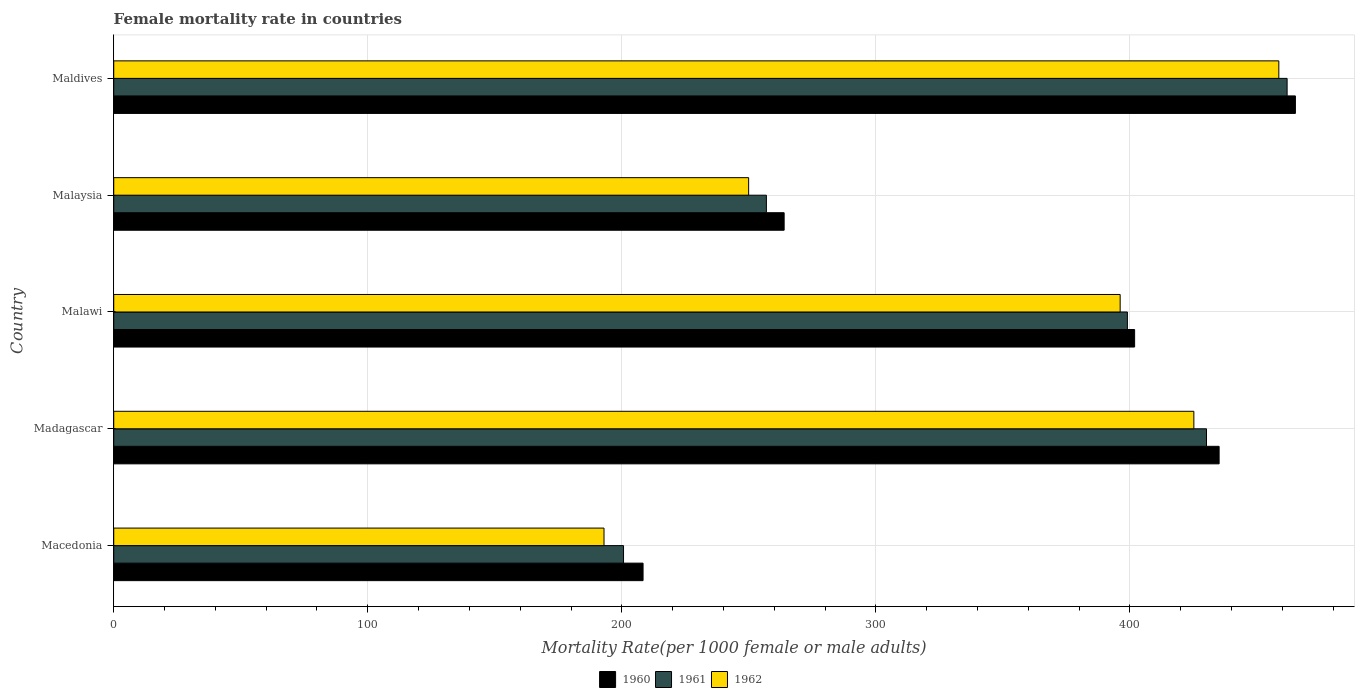How many different coloured bars are there?
Make the answer very short. 3. Are the number of bars on each tick of the Y-axis equal?
Your answer should be very brief. Yes. How many bars are there on the 4th tick from the bottom?
Offer a very short reply. 3. What is the label of the 5th group of bars from the top?
Your response must be concise. Macedonia. What is the female mortality rate in 1961 in Malaysia?
Offer a very short reply. 256.92. Across all countries, what is the maximum female mortality rate in 1961?
Give a very brief answer. 461.9. Across all countries, what is the minimum female mortality rate in 1960?
Keep it short and to the point. 208.37. In which country was the female mortality rate in 1962 maximum?
Your answer should be compact. Maldives. In which country was the female mortality rate in 1960 minimum?
Provide a succinct answer. Macedonia. What is the total female mortality rate in 1961 in the graph?
Provide a succinct answer. 1748.69. What is the difference between the female mortality rate in 1960 in Malaysia and that in Maldives?
Keep it short and to the point. -201.26. What is the difference between the female mortality rate in 1960 in Malawi and the female mortality rate in 1962 in Maldives?
Your answer should be very brief. -56.76. What is the average female mortality rate in 1961 per country?
Your answer should be very brief. 349.74. What is the difference between the female mortality rate in 1960 and female mortality rate in 1962 in Madagascar?
Keep it short and to the point. 9.94. What is the ratio of the female mortality rate in 1960 in Madagascar to that in Maldives?
Provide a succinct answer. 0.94. Is the female mortality rate in 1960 in Madagascar less than that in Maldives?
Your response must be concise. Yes. Is the difference between the female mortality rate in 1960 in Madagascar and Malaysia greater than the difference between the female mortality rate in 1962 in Madagascar and Malaysia?
Provide a succinct answer. No. What is the difference between the highest and the second highest female mortality rate in 1962?
Your answer should be compact. 33.44. What is the difference between the highest and the lowest female mortality rate in 1960?
Your answer should be compact. 256.8. Is the sum of the female mortality rate in 1962 in Macedonia and Madagascar greater than the maximum female mortality rate in 1960 across all countries?
Give a very brief answer. Yes. What does the 1st bar from the top in Maldives represents?
Provide a succinct answer. 1962. What does the 1st bar from the bottom in Maldives represents?
Offer a terse response. 1960. How many bars are there?
Give a very brief answer. 15. Are all the bars in the graph horizontal?
Your answer should be very brief. Yes. Are the values on the major ticks of X-axis written in scientific E-notation?
Your answer should be very brief. No. How are the legend labels stacked?
Make the answer very short. Horizontal. What is the title of the graph?
Make the answer very short. Female mortality rate in countries. What is the label or title of the X-axis?
Make the answer very short. Mortality Rate(per 1000 female or male adults). What is the label or title of the Y-axis?
Your answer should be very brief. Country. What is the Mortality Rate(per 1000 female or male adults) of 1960 in Macedonia?
Your answer should be very brief. 208.37. What is the Mortality Rate(per 1000 female or male adults) in 1961 in Macedonia?
Provide a short and direct response. 200.68. What is the Mortality Rate(per 1000 female or male adults) in 1962 in Macedonia?
Provide a succinct answer. 193. What is the Mortality Rate(per 1000 female or male adults) in 1960 in Madagascar?
Provide a succinct answer. 435.14. What is the Mortality Rate(per 1000 female or male adults) in 1961 in Madagascar?
Provide a succinct answer. 430.17. What is the Mortality Rate(per 1000 female or male adults) in 1962 in Madagascar?
Offer a very short reply. 425.19. What is the Mortality Rate(per 1000 female or male adults) in 1960 in Malawi?
Your response must be concise. 401.87. What is the Mortality Rate(per 1000 female or male adults) in 1961 in Malawi?
Offer a terse response. 399.02. What is the Mortality Rate(per 1000 female or male adults) of 1962 in Malawi?
Offer a terse response. 396.18. What is the Mortality Rate(per 1000 female or male adults) of 1960 in Malaysia?
Your answer should be very brief. 263.9. What is the Mortality Rate(per 1000 female or male adults) of 1961 in Malaysia?
Offer a very short reply. 256.92. What is the Mortality Rate(per 1000 female or male adults) in 1962 in Malaysia?
Make the answer very short. 249.93. What is the Mortality Rate(per 1000 female or male adults) of 1960 in Maldives?
Give a very brief answer. 465.17. What is the Mortality Rate(per 1000 female or male adults) in 1961 in Maldives?
Offer a terse response. 461.9. What is the Mortality Rate(per 1000 female or male adults) in 1962 in Maldives?
Give a very brief answer. 458.64. Across all countries, what is the maximum Mortality Rate(per 1000 female or male adults) of 1960?
Your answer should be compact. 465.17. Across all countries, what is the maximum Mortality Rate(per 1000 female or male adults) in 1961?
Your response must be concise. 461.9. Across all countries, what is the maximum Mortality Rate(per 1000 female or male adults) of 1962?
Make the answer very short. 458.64. Across all countries, what is the minimum Mortality Rate(per 1000 female or male adults) of 1960?
Make the answer very short. 208.37. Across all countries, what is the minimum Mortality Rate(per 1000 female or male adults) in 1961?
Make the answer very short. 200.68. Across all countries, what is the minimum Mortality Rate(per 1000 female or male adults) in 1962?
Provide a succinct answer. 193. What is the total Mortality Rate(per 1000 female or male adults) of 1960 in the graph?
Your answer should be compact. 1774.45. What is the total Mortality Rate(per 1000 female or male adults) of 1961 in the graph?
Provide a succinct answer. 1748.69. What is the total Mortality Rate(per 1000 female or male adults) of 1962 in the graph?
Provide a short and direct response. 1722.93. What is the difference between the Mortality Rate(per 1000 female or male adults) in 1960 in Macedonia and that in Madagascar?
Provide a short and direct response. -226.77. What is the difference between the Mortality Rate(per 1000 female or male adults) in 1961 in Macedonia and that in Madagascar?
Give a very brief answer. -229.48. What is the difference between the Mortality Rate(per 1000 female or male adults) of 1962 in Macedonia and that in Madagascar?
Offer a very short reply. -232.2. What is the difference between the Mortality Rate(per 1000 female or male adults) of 1960 in Macedonia and that in Malawi?
Offer a very short reply. -193.51. What is the difference between the Mortality Rate(per 1000 female or male adults) of 1961 in Macedonia and that in Malawi?
Make the answer very short. -198.34. What is the difference between the Mortality Rate(per 1000 female or male adults) in 1962 in Macedonia and that in Malawi?
Ensure brevity in your answer.  -203.18. What is the difference between the Mortality Rate(per 1000 female or male adults) in 1960 in Macedonia and that in Malaysia?
Ensure brevity in your answer.  -55.54. What is the difference between the Mortality Rate(per 1000 female or male adults) of 1961 in Macedonia and that in Malaysia?
Your response must be concise. -56.23. What is the difference between the Mortality Rate(per 1000 female or male adults) of 1962 in Macedonia and that in Malaysia?
Make the answer very short. -56.93. What is the difference between the Mortality Rate(per 1000 female or male adults) of 1960 in Macedonia and that in Maldives?
Provide a short and direct response. -256.8. What is the difference between the Mortality Rate(per 1000 female or male adults) of 1961 in Macedonia and that in Maldives?
Keep it short and to the point. -261.22. What is the difference between the Mortality Rate(per 1000 female or male adults) in 1962 in Macedonia and that in Maldives?
Make the answer very short. -265.64. What is the difference between the Mortality Rate(per 1000 female or male adults) of 1960 in Madagascar and that in Malawi?
Your response must be concise. 33.26. What is the difference between the Mortality Rate(per 1000 female or male adults) of 1961 in Madagascar and that in Malawi?
Make the answer very short. 31.14. What is the difference between the Mortality Rate(per 1000 female or male adults) of 1962 in Madagascar and that in Malawi?
Provide a succinct answer. 29.02. What is the difference between the Mortality Rate(per 1000 female or male adults) of 1960 in Madagascar and that in Malaysia?
Your response must be concise. 171.23. What is the difference between the Mortality Rate(per 1000 female or male adults) in 1961 in Madagascar and that in Malaysia?
Offer a terse response. 173.25. What is the difference between the Mortality Rate(per 1000 female or male adults) of 1962 in Madagascar and that in Malaysia?
Your response must be concise. 175.26. What is the difference between the Mortality Rate(per 1000 female or male adults) of 1960 in Madagascar and that in Maldives?
Offer a terse response. -30.03. What is the difference between the Mortality Rate(per 1000 female or male adults) of 1961 in Madagascar and that in Maldives?
Offer a very short reply. -31.74. What is the difference between the Mortality Rate(per 1000 female or male adults) in 1962 in Madagascar and that in Maldives?
Give a very brief answer. -33.44. What is the difference between the Mortality Rate(per 1000 female or male adults) of 1960 in Malawi and that in Malaysia?
Make the answer very short. 137.97. What is the difference between the Mortality Rate(per 1000 female or male adults) in 1961 in Malawi and that in Malaysia?
Give a very brief answer. 142.11. What is the difference between the Mortality Rate(per 1000 female or male adults) of 1962 in Malawi and that in Malaysia?
Provide a short and direct response. 146.25. What is the difference between the Mortality Rate(per 1000 female or male adults) of 1960 in Malawi and that in Maldives?
Your answer should be compact. -63.29. What is the difference between the Mortality Rate(per 1000 female or male adults) of 1961 in Malawi and that in Maldives?
Keep it short and to the point. -62.88. What is the difference between the Mortality Rate(per 1000 female or male adults) in 1962 in Malawi and that in Maldives?
Offer a very short reply. -62.46. What is the difference between the Mortality Rate(per 1000 female or male adults) of 1960 in Malaysia and that in Maldives?
Offer a terse response. -201.26. What is the difference between the Mortality Rate(per 1000 female or male adults) in 1961 in Malaysia and that in Maldives?
Offer a terse response. -204.98. What is the difference between the Mortality Rate(per 1000 female or male adults) of 1962 in Malaysia and that in Maldives?
Ensure brevity in your answer.  -208.71. What is the difference between the Mortality Rate(per 1000 female or male adults) in 1960 in Macedonia and the Mortality Rate(per 1000 female or male adults) in 1961 in Madagascar?
Make the answer very short. -221.8. What is the difference between the Mortality Rate(per 1000 female or male adults) of 1960 in Macedonia and the Mortality Rate(per 1000 female or male adults) of 1962 in Madagascar?
Give a very brief answer. -216.82. What is the difference between the Mortality Rate(per 1000 female or male adults) in 1961 in Macedonia and the Mortality Rate(per 1000 female or male adults) in 1962 in Madagascar?
Keep it short and to the point. -224.51. What is the difference between the Mortality Rate(per 1000 female or male adults) of 1960 in Macedonia and the Mortality Rate(per 1000 female or male adults) of 1961 in Malawi?
Ensure brevity in your answer.  -190.66. What is the difference between the Mortality Rate(per 1000 female or male adults) of 1960 in Macedonia and the Mortality Rate(per 1000 female or male adults) of 1962 in Malawi?
Provide a succinct answer. -187.81. What is the difference between the Mortality Rate(per 1000 female or male adults) in 1961 in Macedonia and the Mortality Rate(per 1000 female or male adults) in 1962 in Malawi?
Offer a terse response. -195.49. What is the difference between the Mortality Rate(per 1000 female or male adults) in 1960 in Macedonia and the Mortality Rate(per 1000 female or male adults) in 1961 in Malaysia?
Your answer should be very brief. -48.55. What is the difference between the Mortality Rate(per 1000 female or male adults) of 1960 in Macedonia and the Mortality Rate(per 1000 female or male adults) of 1962 in Malaysia?
Your response must be concise. -41.56. What is the difference between the Mortality Rate(per 1000 female or male adults) in 1961 in Macedonia and the Mortality Rate(per 1000 female or male adults) in 1962 in Malaysia?
Give a very brief answer. -49.24. What is the difference between the Mortality Rate(per 1000 female or male adults) of 1960 in Macedonia and the Mortality Rate(per 1000 female or male adults) of 1961 in Maldives?
Your answer should be compact. -253.53. What is the difference between the Mortality Rate(per 1000 female or male adults) in 1960 in Macedonia and the Mortality Rate(per 1000 female or male adults) in 1962 in Maldives?
Keep it short and to the point. -250.27. What is the difference between the Mortality Rate(per 1000 female or male adults) of 1961 in Macedonia and the Mortality Rate(per 1000 female or male adults) of 1962 in Maldives?
Your answer should be very brief. -257.95. What is the difference between the Mortality Rate(per 1000 female or male adults) of 1960 in Madagascar and the Mortality Rate(per 1000 female or male adults) of 1961 in Malawi?
Provide a succinct answer. 36.11. What is the difference between the Mortality Rate(per 1000 female or male adults) of 1960 in Madagascar and the Mortality Rate(per 1000 female or male adults) of 1962 in Malawi?
Keep it short and to the point. 38.96. What is the difference between the Mortality Rate(per 1000 female or male adults) in 1961 in Madagascar and the Mortality Rate(per 1000 female or male adults) in 1962 in Malawi?
Your answer should be very brief. 33.99. What is the difference between the Mortality Rate(per 1000 female or male adults) of 1960 in Madagascar and the Mortality Rate(per 1000 female or male adults) of 1961 in Malaysia?
Your answer should be very brief. 178.22. What is the difference between the Mortality Rate(per 1000 female or male adults) in 1960 in Madagascar and the Mortality Rate(per 1000 female or male adults) in 1962 in Malaysia?
Ensure brevity in your answer.  185.21. What is the difference between the Mortality Rate(per 1000 female or male adults) of 1961 in Madagascar and the Mortality Rate(per 1000 female or male adults) of 1962 in Malaysia?
Keep it short and to the point. 180.24. What is the difference between the Mortality Rate(per 1000 female or male adults) of 1960 in Madagascar and the Mortality Rate(per 1000 female or male adults) of 1961 in Maldives?
Offer a terse response. -26.77. What is the difference between the Mortality Rate(per 1000 female or male adults) of 1960 in Madagascar and the Mortality Rate(per 1000 female or male adults) of 1962 in Maldives?
Keep it short and to the point. -23.5. What is the difference between the Mortality Rate(per 1000 female or male adults) of 1961 in Madagascar and the Mortality Rate(per 1000 female or male adults) of 1962 in Maldives?
Offer a terse response. -28.47. What is the difference between the Mortality Rate(per 1000 female or male adults) in 1960 in Malawi and the Mortality Rate(per 1000 female or male adults) in 1961 in Malaysia?
Your answer should be very brief. 144.96. What is the difference between the Mortality Rate(per 1000 female or male adults) of 1960 in Malawi and the Mortality Rate(per 1000 female or male adults) of 1962 in Malaysia?
Provide a succinct answer. 151.95. What is the difference between the Mortality Rate(per 1000 female or male adults) in 1961 in Malawi and the Mortality Rate(per 1000 female or male adults) in 1962 in Malaysia?
Your response must be concise. 149.1. What is the difference between the Mortality Rate(per 1000 female or male adults) of 1960 in Malawi and the Mortality Rate(per 1000 female or male adults) of 1961 in Maldives?
Offer a terse response. -60.03. What is the difference between the Mortality Rate(per 1000 female or male adults) in 1960 in Malawi and the Mortality Rate(per 1000 female or male adults) in 1962 in Maldives?
Give a very brief answer. -56.76. What is the difference between the Mortality Rate(per 1000 female or male adults) in 1961 in Malawi and the Mortality Rate(per 1000 female or male adults) in 1962 in Maldives?
Make the answer very short. -59.61. What is the difference between the Mortality Rate(per 1000 female or male adults) of 1960 in Malaysia and the Mortality Rate(per 1000 female or male adults) of 1961 in Maldives?
Your answer should be very brief. -198. What is the difference between the Mortality Rate(per 1000 female or male adults) of 1960 in Malaysia and the Mortality Rate(per 1000 female or male adults) of 1962 in Maldives?
Provide a short and direct response. -194.73. What is the difference between the Mortality Rate(per 1000 female or male adults) of 1961 in Malaysia and the Mortality Rate(per 1000 female or male adults) of 1962 in Maldives?
Your answer should be very brief. -201.72. What is the average Mortality Rate(per 1000 female or male adults) of 1960 per country?
Make the answer very short. 354.89. What is the average Mortality Rate(per 1000 female or male adults) in 1961 per country?
Provide a short and direct response. 349.74. What is the average Mortality Rate(per 1000 female or male adults) of 1962 per country?
Provide a succinct answer. 344.59. What is the difference between the Mortality Rate(per 1000 female or male adults) in 1960 and Mortality Rate(per 1000 female or male adults) in 1961 in Macedonia?
Give a very brief answer. 7.68. What is the difference between the Mortality Rate(per 1000 female or male adults) in 1960 and Mortality Rate(per 1000 female or male adults) in 1962 in Macedonia?
Keep it short and to the point. 15.37. What is the difference between the Mortality Rate(per 1000 female or male adults) in 1961 and Mortality Rate(per 1000 female or male adults) in 1962 in Macedonia?
Make the answer very short. 7.69. What is the difference between the Mortality Rate(per 1000 female or male adults) in 1960 and Mortality Rate(per 1000 female or male adults) in 1961 in Madagascar?
Your response must be concise. 4.97. What is the difference between the Mortality Rate(per 1000 female or male adults) of 1960 and Mortality Rate(per 1000 female or male adults) of 1962 in Madagascar?
Your response must be concise. 9.94. What is the difference between the Mortality Rate(per 1000 female or male adults) of 1961 and Mortality Rate(per 1000 female or male adults) of 1962 in Madagascar?
Keep it short and to the point. 4.97. What is the difference between the Mortality Rate(per 1000 female or male adults) in 1960 and Mortality Rate(per 1000 female or male adults) in 1961 in Malawi?
Ensure brevity in your answer.  2.85. What is the difference between the Mortality Rate(per 1000 female or male adults) in 1960 and Mortality Rate(per 1000 female or male adults) in 1962 in Malawi?
Provide a succinct answer. 5.7. What is the difference between the Mortality Rate(per 1000 female or male adults) of 1961 and Mortality Rate(per 1000 female or male adults) of 1962 in Malawi?
Your response must be concise. 2.85. What is the difference between the Mortality Rate(per 1000 female or male adults) in 1960 and Mortality Rate(per 1000 female or male adults) in 1961 in Malaysia?
Offer a very short reply. 6.99. What is the difference between the Mortality Rate(per 1000 female or male adults) of 1960 and Mortality Rate(per 1000 female or male adults) of 1962 in Malaysia?
Provide a short and direct response. 13.98. What is the difference between the Mortality Rate(per 1000 female or male adults) of 1961 and Mortality Rate(per 1000 female or male adults) of 1962 in Malaysia?
Offer a very short reply. 6.99. What is the difference between the Mortality Rate(per 1000 female or male adults) in 1960 and Mortality Rate(per 1000 female or male adults) in 1961 in Maldives?
Keep it short and to the point. 3.27. What is the difference between the Mortality Rate(per 1000 female or male adults) in 1960 and Mortality Rate(per 1000 female or male adults) in 1962 in Maldives?
Your answer should be compact. 6.53. What is the difference between the Mortality Rate(per 1000 female or male adults) of 1961 and Mortality Rate(per 1000 female or male adults) of 1962 in Maldives?
Your response must be concise. 3.27. What is the ratio of the Mortality Rate(per 1000 female or male adults) of 1960 in Macedonia to that in Madagascar?
Give a very brief answer. 0.48. What is the ratio of the Mortality Rate(per 1000 female or male adults) in 1961 in Macedonia to that in Madagascar?
Make the answer very short. 0.47. What is the ratio of the Mortality Rate(per 1000 female or male adults) in 1962 in Macedonia to that in Madagascar?
Give a very brief answer. 0.45. What is the ratio of the Mortality Rate(per 1000 female or male adults) in 1960 in Macedonia to that in Malawi?
Make the answer very short. 0.52. What is the ratio of the Mortality Rate(per 1000 female or male adults) in 1961 in Macedonia to that in Malawi?
Give a very brief answer. 0.5. What is the ratio of the Mortality Rate(per 1000 female or male adults) in 1962 in Macedonia to that in Malawi?
Your response must be concise. 0.49. What is the ratio of the Mortality Rate(per 1000 female or male adults) in 1960 in Macedonia to that in Malaysia?
Your response must be concise. 0.79. What is the ratio of the Mortality Rate(per 1000 female or male adults) of 1961 in Macedonia to that in Malaysia?
Make the answer very short. 0.78. What is the ratio of the Mortality Rate(per 1000 female or male adults) of 1962 in Macedonia to that in Malaysia?
Offer a terse response. 0.77. What is the ratio of the Mortality Rate(per 1000 female or male adults) in 1960 in Macedonia to that in Maldives?
Your answer should be very brief. 0.45. What is the ratio of the Mortality Rate(per 1000 female or male adults) of 1961 in Macedonia to that in Maldives?
Offer a terse response. 0.43. What is the ratio of the Mortality Rate(per 1000 female or male adults) of 1962 in Macedonia to that in Maldives?
Your answer should be compact. 0.42. What is the ratio of the Mortality Rate(per 1000 female or male adults) of 1960 in Madagascar to that in Malawi?
Your answer should be compact. 1.08. What is the ratio of the Mortality Rate(per 1000 female or male adults) of 1961 in Madagascar to that in Malawi?
Ensure brevity in your answer.  1.08. What is the ratio of the Mortality Rate(per 1000 female or male adults) in 1962 in Madagascar to that in Malawi?
Your answer should be compact. 1.07. What is the ratio of the Mortality Rate(per 1000 female or male adults) of 1960 in Madagascar to that in Malaysia?
Give a very brief answer. 1.65. What is the ratio of the Mortality Rate(per 1000 female or male adults) in 1961 in Madagascar to that in Malaysia?
Ensure brevity in your answer.  1.67. What is the ratio of the Mortality Rate(per 1000 female or male adults) of 1962 in Madagascar to that in Malaysia?
Offer a very short reply. 1.7. What is the ratio of the Mortality Rate(per 1000 female or male adults) of 1960 in Madagascar to that in Maldives?
Provide a succinct answer. 0.94. What is the ratio of the Mortality Rate(per 1000 female or male adults) in 1961 in Madagascar to that in Maldives?
Your answer should be very brief. 0.93. What is the ratio of the Mortality Rate(per 1000 female or male adults) in 1962 in Madagascar to that in Maldives?
Offer a very short reply. 0.93. What is the ratio of the Mortality Rate(per 1000 female or male adults) of 1960 in Malawi to that in Malaysia?
Provide a short and direct response. 1.52. What is the ratio of the Mortality Rate(per 1000 female or male adults) in 1961 in Malawi to that in Malaysia?
Your response must be concise. 1.55. What is the ratio of the Mortality Rate(per 1000 female or male adults) in 1962 in Malawi to that in Malaysia?
Your answer should be very brief. 1.59. What is the ratio of the Mortality Rate(per 1000 female or male adults) of 1960 in Malawi to that in Maldives?
Ensure brevity in your answer.  0.86. What is the ratio of the Mortality Rate(per 1000 female or male adults) in 1961 in Malawi to that in Maldives?
Your answer should be very brief. 0.86. What is the ratio of the Mortality Rate(per 1000 female or male adults) of 1962 in Malawi to that in Maldives?
Keep it short and to the point. 0.86. What is the ratio of the Mortality Rate(per 1000 female or male adults) of 1960 in Malaysia to that in Maldives?
Give a very brief answer. 0.57. What is the ratio of the Mortality Rate(per 1000 female or male adults) in 1961 in Malaysia to that in Maldives?
Ensure brevity in your answer.  0.56. What is the ratio of the Mortality Rate(per 1000 female or male adults) in 1962 in Malaysia to that in Maldives?
Offer a very short reply. 0.54. What is the difference between the highest and the second highest Mortality Rate(per 1000 female or male adults) of 1960?
Keep it short and to the point. 30.03. What is the difference between the highest and the second highest Mortality Rate(per 1000 female or male adults) in 1961?
Give a very brief answer. 31.74. What is the difference between the highest and the second highest Mortality Rate(per 1000 female or male adults) of 1962?
Offer a very short reply. 33.44. What is the difference between the highest and the lowest Mortality Rate(per 1000 female or male adults) in 1960?
Make the answer very short. 256.8. What is the difference between the highest and the lowest Mortality Rate(per 1000 female or male adults) of 1961?
Your answer should be compact. 261.22. What is the difference between the highest and the lowest Mortality Rate(per 1000 female or male adults) of 1962?
Ensure brevity in your answer.  265.64. 